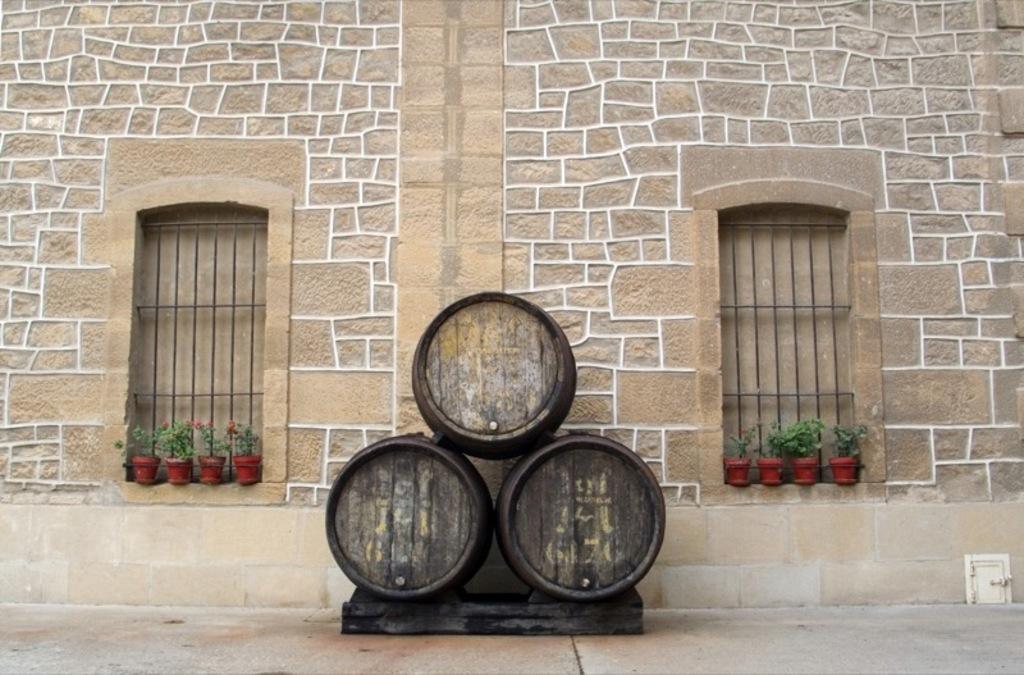Describe this image in one or two sentences. In this image we can see a building, there are some windows and flower pots, on the floor we can see a black color object. 